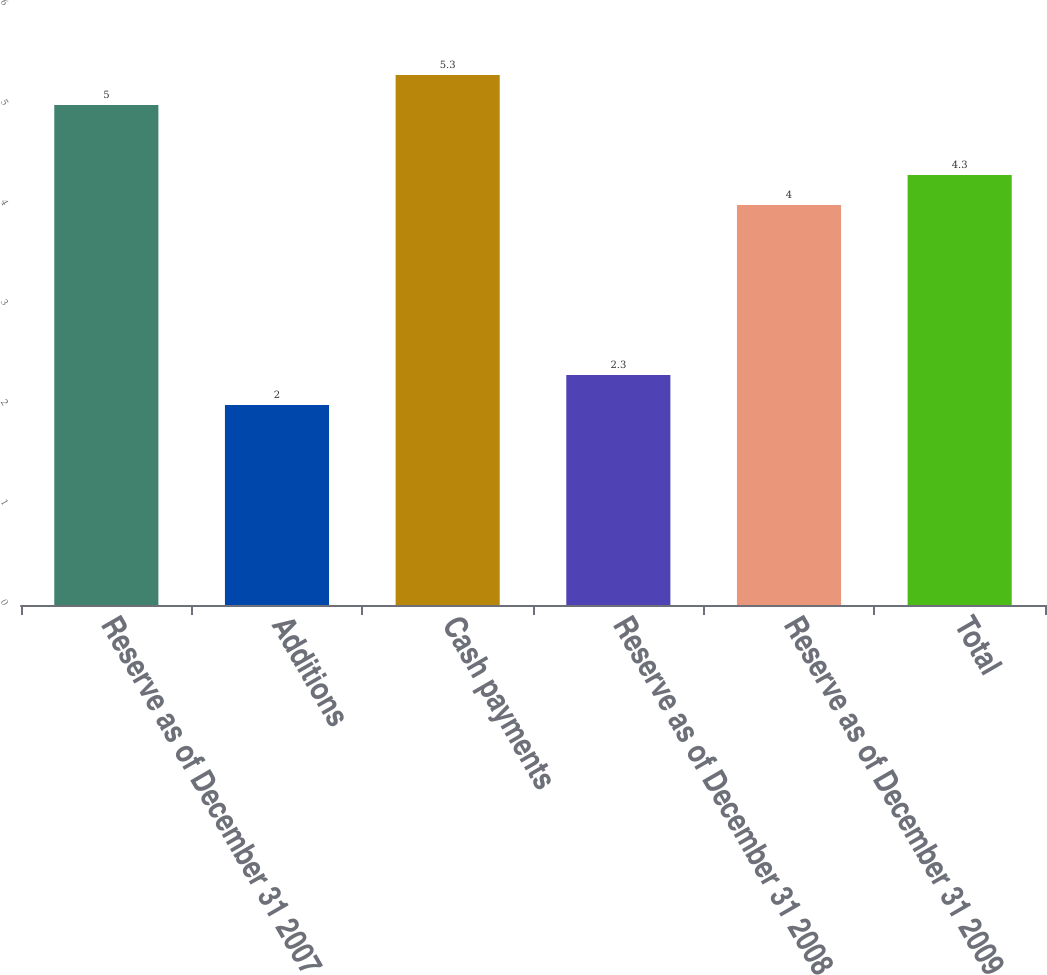Convert chart to OTSL. <chart><loc_0><loc_0><loc_500><loc_500><bar_chart><fcel>Reserve as of December 31 2007<fcel>Additions<fcel>Cash payments<fcel>Reserve as of December 31 2008<fcel>Reserve as of December 31 2009<fcel>Total<nl><fcel>5<fcel>2<fcel>5.3<fcel>2.3<fcel>4<fcel>4.3<nl></chart> 